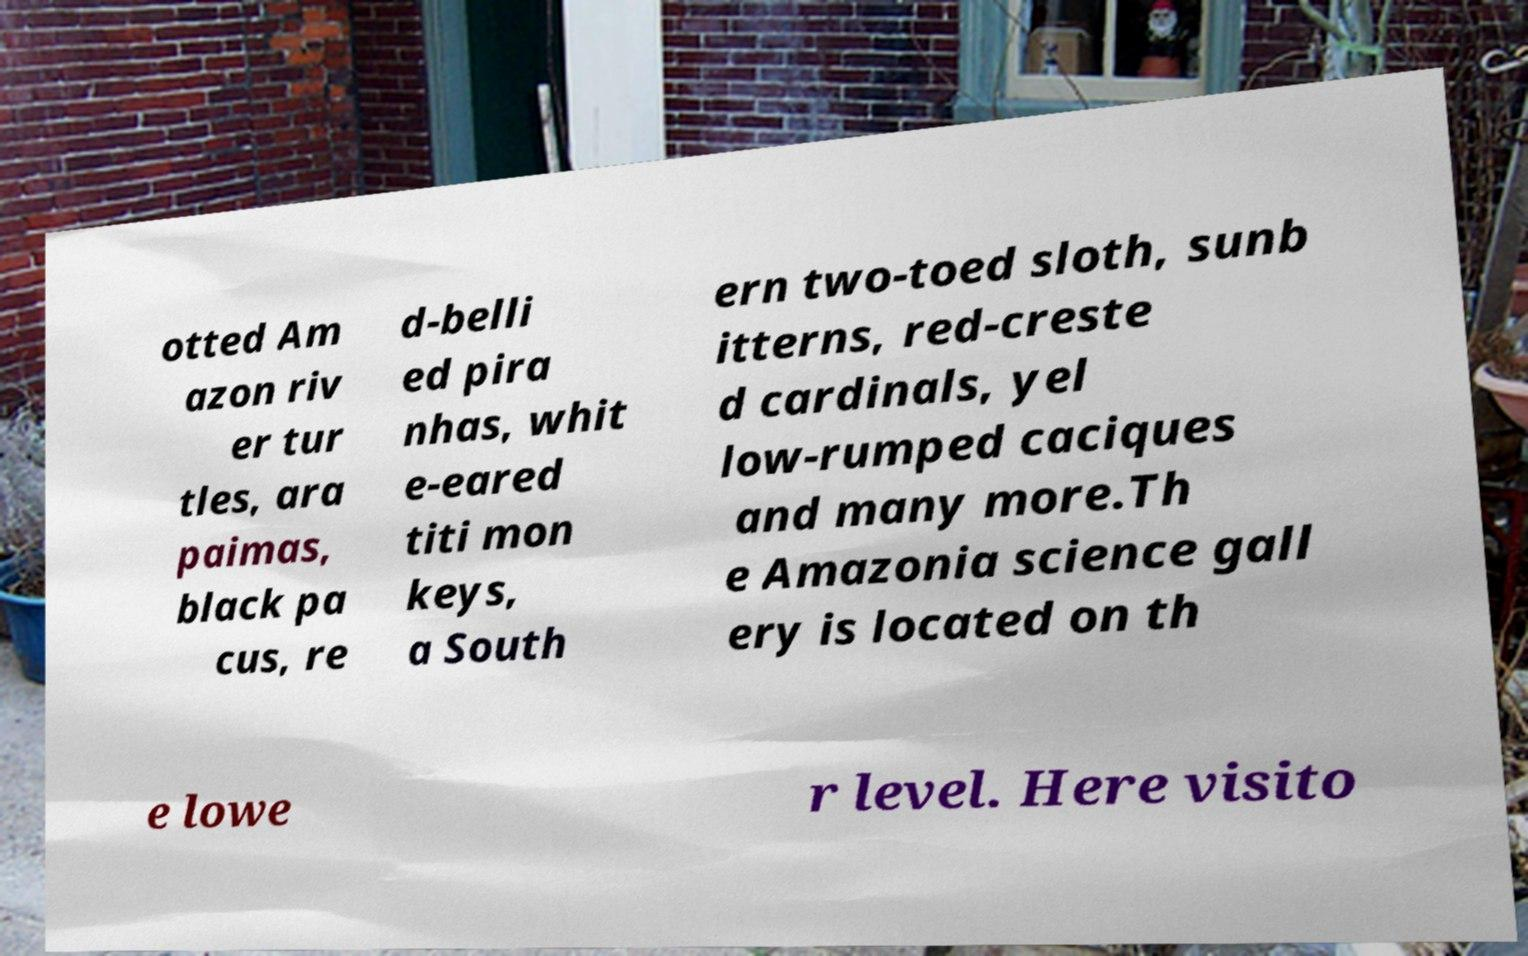What messages or text are displayed in this image? I need them in a readable, typed format. otted Am azon riv er tur tles, ara paimas, black pa cus, re d-belli ed pira nhas, whit e-eared titi mon keys, a South ern two-toed sloth, sunb itterns, red-creste d cardinals, yel low-rumped caciques and many more.Th e Amazonia science gall ery is located on th e lowe r level. Here visito 